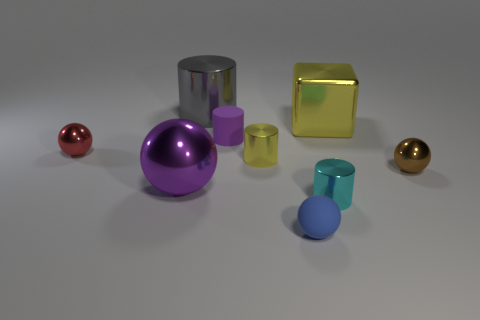Can you tell me the number of geometric shapes present in this image? Certainly! There are seven distinct geometric shapes: two spheres (one red, one gold), two cylinders (one large gray, one small yellow), a cube (gold), a small teal-colored torus, and a blue object that resembles a capsule or pill shape. Which of these shapes does not share its color with any other? The red sphere is the only object in the image with its unique color; no other shapes share this shade. 